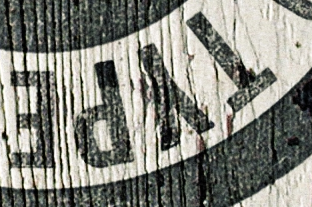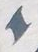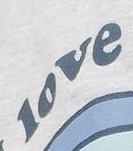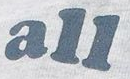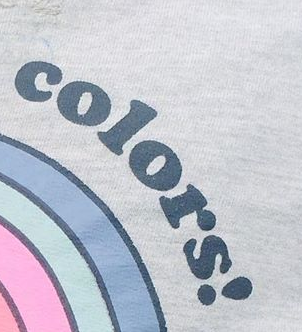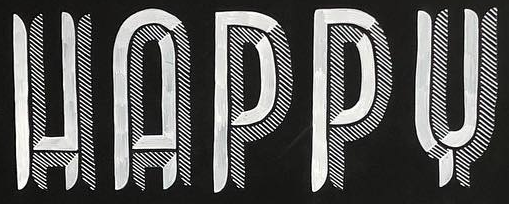What text appears in these images from left to right, separated by a semicolon? TYPE; I; love; all; colors!; HAPPY 